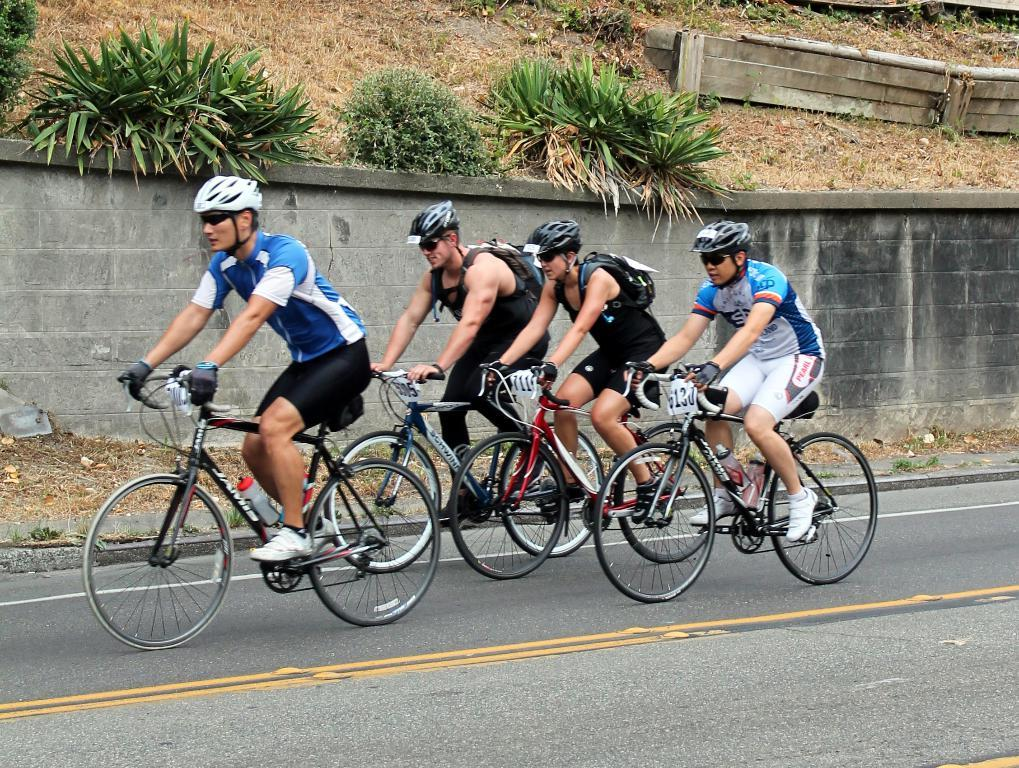How many people are in the image? There are four men in the image. What are the men doing in the image? The men are riding bicycles. Where are the men located in the image? The men are on the road. What can be seen on the side of the road in the image? There are plants visible on the side of the road. How many ladybugs can be seen on the men's helmets in the image? There are no ladybugs visible on the men's helmets in the image. What type of brain activity can be observed in the men's faces in the image? There is no indication of brain activity in the men's faces in the image; we can only see their expressions while riding bicycles. 